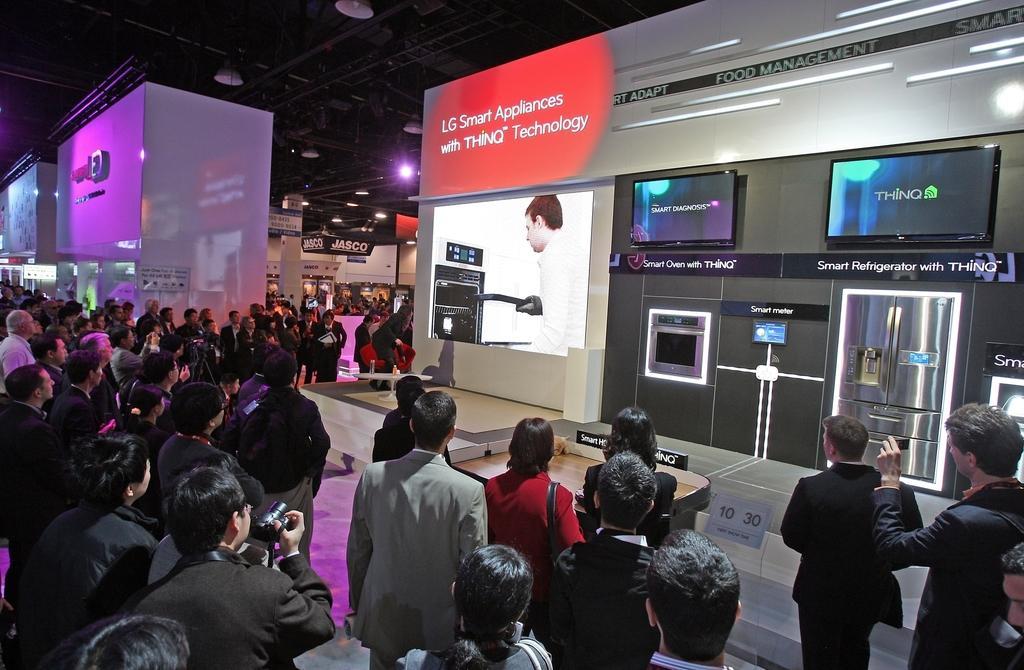Could you give a brief overview of what you see in this image? In the picture we can see a showroom with electronic items are kept and some people are watching it and in the background, we can see some pillar and some lights in the ceiling. 